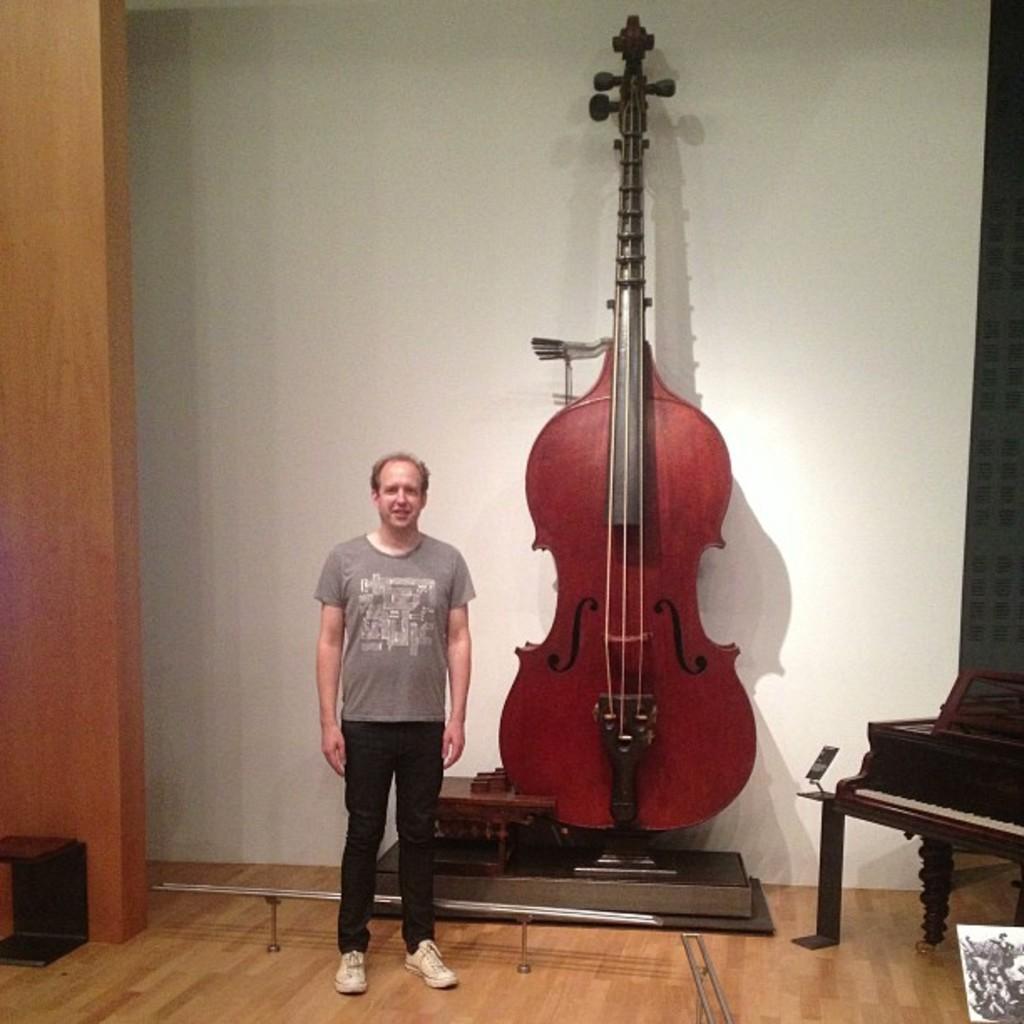Can you describe this image briefly? In this picture, a man is standing. There is a giant violin beside him. The man wears ash colored T shirt with black pant and casual shoes. 